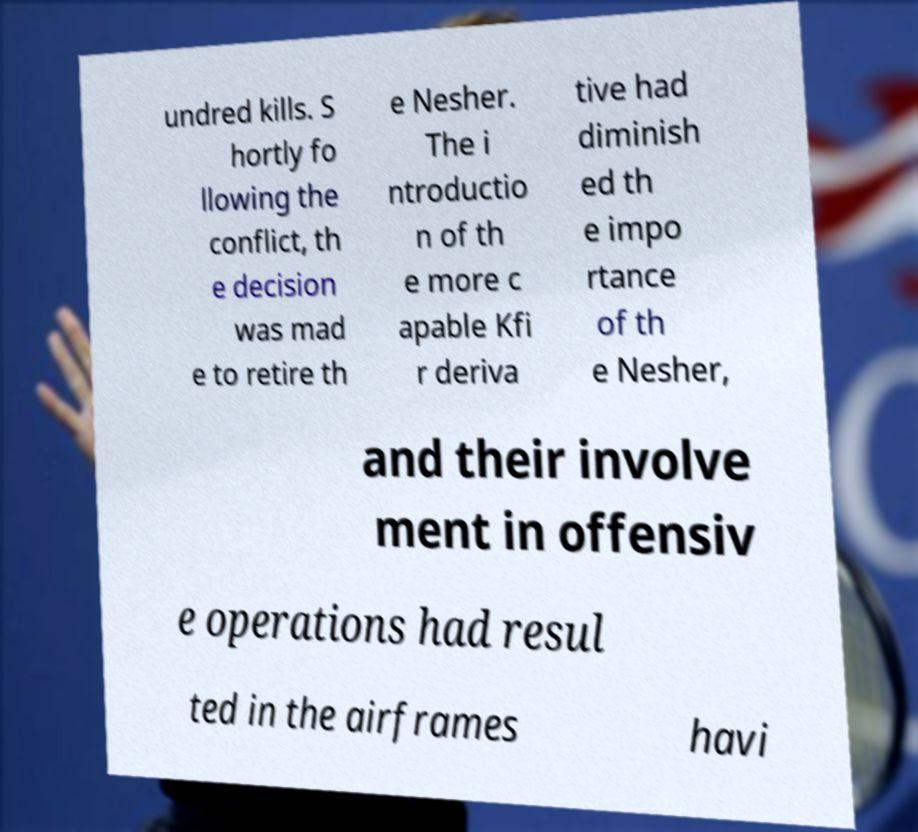I need the written content from this picture converted into text. Can you do that? undred kills. S hortly fo llowing the conflict, th e decision was mad e to retire th e Nesher. The i ntroductio n of th e more c apable Kfi r deriva tive had diminish ed th e impo rtance of th e Nesher, and their involve ment in offensiv e operations had resul ted in the airframes havi 